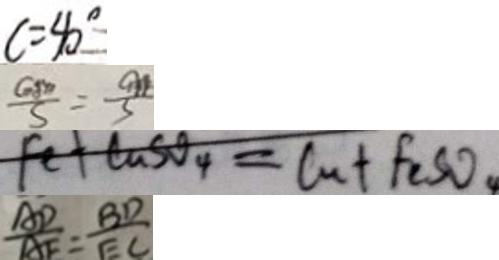Convert formula to latex. <formula><loc_0><loc_0><loc_500><loc_500>c = 4 0 ^ { \circ } 
 \frac { G M } { S } = \frac { a } { 3 } 
 F e + C u S O _ { 4 } = C u + F _ { 2 } S O _ { 4 } 
 \frac { A D } { A E } = \frac { B D } { E C }</formula> 